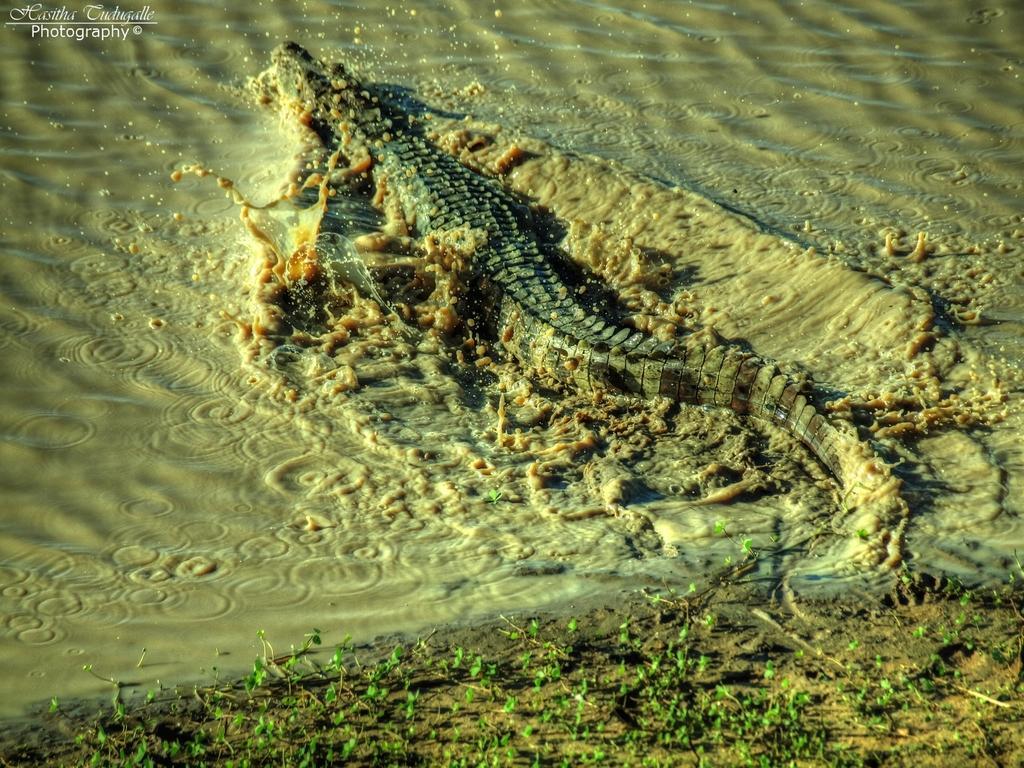Can you describe this image briefly? In this picture, we can see a crocodile in water, we can see the ground with plants, and some watermark in the top left corner of the picture. 